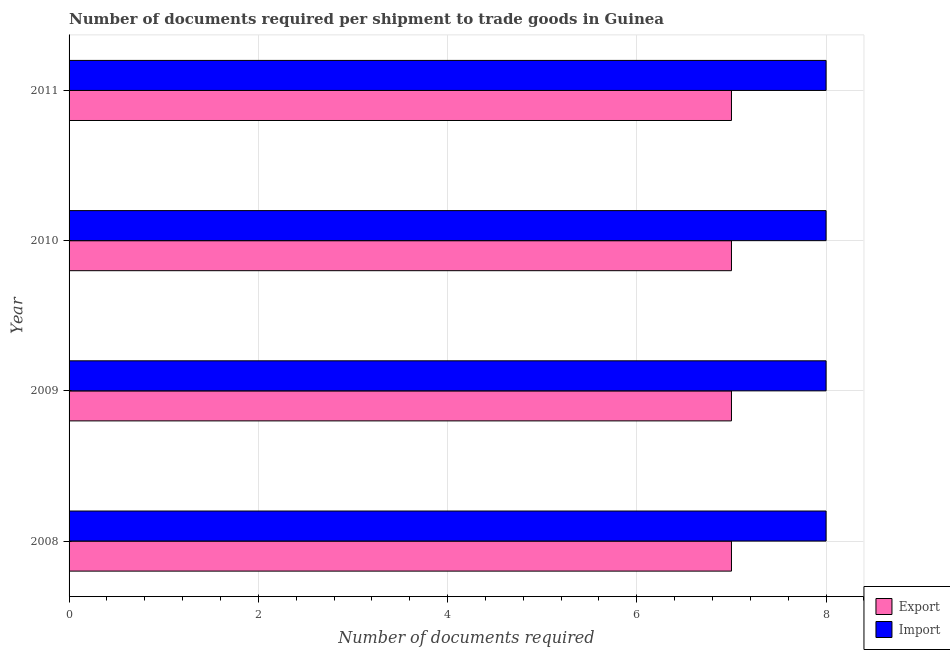Are the number of bars per tick equal to the number of legend labels?
Keep it short and to the point. Yes. What is the label of the 3rd group of bars from the top?
Make the answer very short. 2009. In how many cases, is the number of bars for a given year not equal to the number of legend labels?
Your response must be concise. 0. What is the number of documents required to export goods in 2008?
Provide a short and direct response. 7. Across all years, what is the maximum number of documents required to import goods?
Make the answer very short. 8. Across all years, what is the minimum number of documents required to import goods?
Your response must be concise. 8. What is the total number of documents required to export goods in the graph?
Offer a terse response. 28. What is the difference between the number of documents required to export goods in 2009 and the number of documents required to import goods in 2011?
Give a very brief answer. -1. In the year 2011, what is the difference between the number of documents required to import goods and number of documents required to export goods?
Offer a very short reply. 1. What is the difference between the highest and the second highest number of documents required to export goods?
Make the answer very short. 0. In how many years, is the number of documents required to import goods greater than the average number of documents required to import goods taken over all years?
Ensure brevity in your answer.  0. What does the 1st bar from the top in 2011 represents?
Keep it short and to the point. Import. What does the 2nd bar from the bottom in 2008 represents?
Offer a terse response. Import. How many bars are there?
Offer a terse response. 8. How many years are there in the graph?
Give a very brief answer. 4. Are the values on the major ticks of X-axis written in scientific E-notation?
Ensure brevity in your answer.  No. Does the graph contain any zero values?
Offer a terse response. No. Where does the legend appear in the graph?
Keep it short and to the point. Bottom right. How many legend labels are there?
Your answer should be very brief. 2. What is the title of the graph?
Your response must be concise. Number of documents required per shipment to trade goods in Guinea. What is the label or title of the X-axis?
Your answer should be very brief. Number of documents required. What is the Number of documents required in Import in 2008?
Offer a terse response. 8. What is the Number of documents required in Export in 2010?
Ensure brevity in your answer.  7. What is the Number of documents required in Export in 2011?
Offer a terse response. 7. What is the Number of documents required in Import in 2011?
Your response must be concise. 8. Across all years, what is the maximum Number of documents required in Export?
Ensure brevity in your answer.  7. Across all years, what is the maximum Number of documents required of Import?
Your answer should be compact. 8. Across all years, what is the minimum Number of documents required of Import?
Keep it short and to the point. 8. What is the total Number of documents required in Import in the graph?
Your answer should be very brief. 32. What is the difference between the Number of documents required of Export in 2008 and that in 2009?
Offer a terse response. 0. What is the difference between the Number of documents required of Import in 2008 and that in 2010?
Offer a terse response. 0. What is the difference between the Number of documents required of Export in 2009 and that in 2010?
Ensure brevity in your answer.  0. What is the difference between the Number of documents required in Import in 2009 and that in 2010?
Make the answer very short. 0. What is the difference between the Number of documents required in Export in 2008 and the Number of documents required in Import in 2009?
Offer a terse response. -1. What is the difference between the Number of documents required in Export in 2008 and the Number of documents required in Import in 2010?
Offer a terse response. -1. What is the difference between the Number of documents required of Export in 2008 and the Number of documents required of Import in 2011?
Your response must be concise. -1. What is the difference between the Number of documents required in Export in 2009 and the Number of documents required in Import in 2010?
Ensure brevity in your answer.  -1. What is the difference between the Number of documents required in Export in 2009 and the Number of documents required in Import in 2011?
Your response must be concise. -1. What is the difference between the Number of documents required in Export in 2010 and the Number of documents required in Import in 2011?
Give a very brief answer. -1. What is the average Number of documents required in Export per year?
Your answer should be compact. 7. What is the average Number of documents required in Import per year?
Your answer should be compact. 8. In the year 2008, what is the difference between the Number of documents required in Export and Number of documents required in Import?
Ensure brevity in your answer.  -1. In the year 2009, what is the difference between the Number of documents required of Export and Number of documents required of Import?
Your answer should be very brief. -1. In the year 2010, what is the difference between the Number of documents required of Export and Number of documents required of Import?
Make the answer very short. -1. In the year 2011, what is the difference between the Number of documents required in Export and Number of documents required in Import?
Make the answer very short. -1. What is the ratio of the Number of documents required in Export in 2008 to that in 2009?
Your answer should be very brief. 1. What is the ratio of the Number of documents required of Import in 2008 to that in 2011?
Ensure brevity in your answer.  1. What is the ratio of the Number of documents required in Import in 2009 to that in 2010?
Offer a very short reply. 1. What is the ratio of the Number of documents required of Export in 2010 to that in 2011?
Your answer should be compact. 1. What is the ratio of the Number of documents required in Import in 2010 to that in 2011?
Make the answer very short. 1. What is the difference between the highest and the second highest Number of documents required of Export?
Ensure brevity in your answer.  0. What is the difference between the highest and the second highest Number of documents required of Import?
Make the answer very short. 0. 